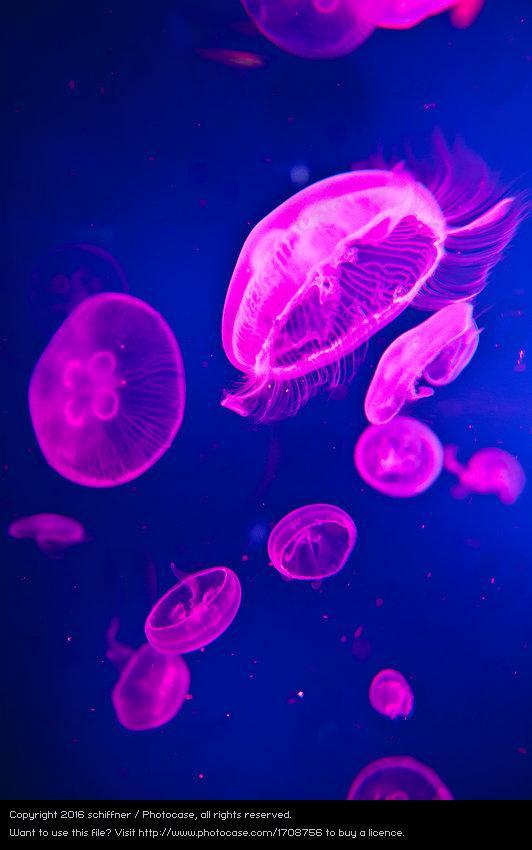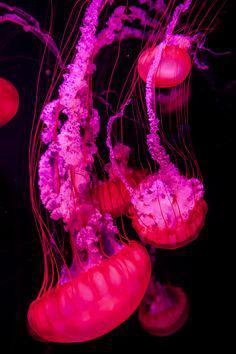The first image is the image on the left, the second image is the image on the right. Evaluate the accuracy of this statement regarding the images: "There are multiple jellyfish in water in the right image.". Is it true? Answer yes or no. Yes. The first image is the image on the left, the second image is the image on the right. Evaluate the accuracy of this statement regarding the images: "Left image shows multiple disk-shaped hot-pink jellyfish on a blue background.". Is it true? Answer yes or no. Yes. 